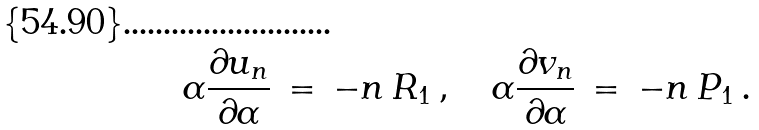Convert formula to latex. <formula><loc_0><loc_0><loc_500><loc_500>\alpha \frac { \partial u _ { n } } { \partial \alpha } \, = \, - n \, { R } _ { 1 } \, , \quad \alpha \frac { \partial v _ { n } } { \partial \alpha } \, = \, - n \, { P } _ { 1 } \, .</formula> 